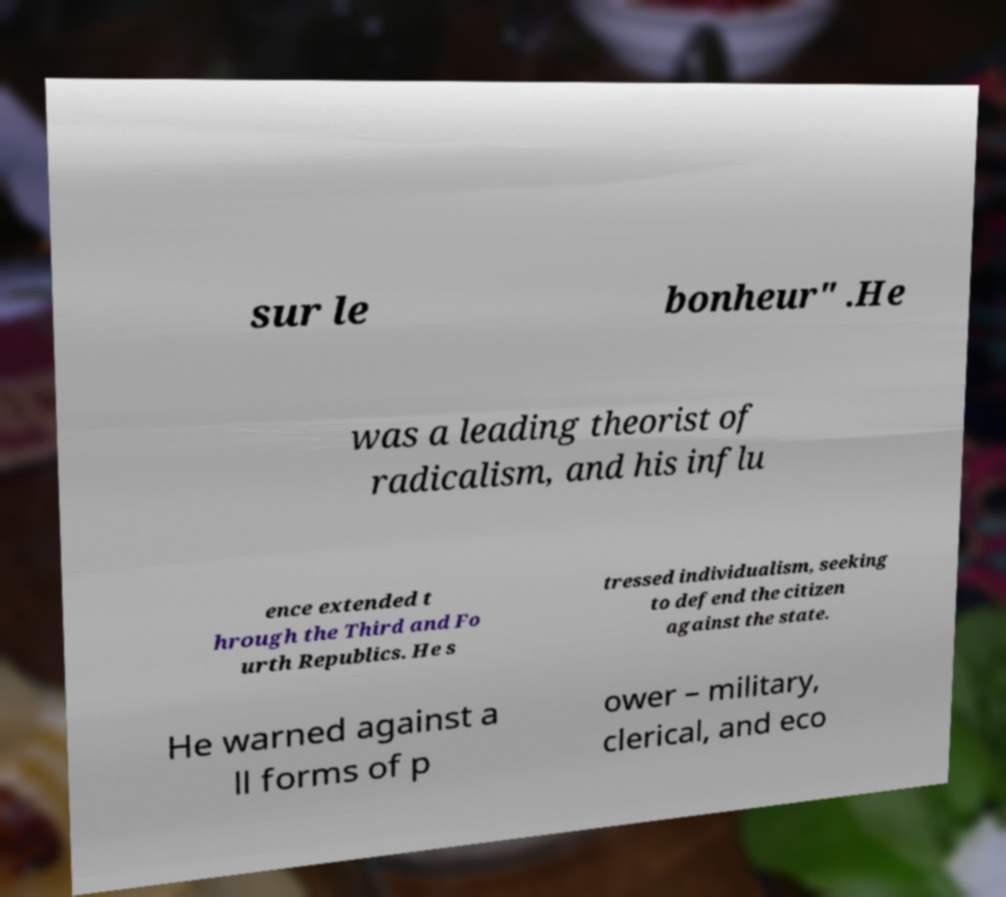What messages or text are displayed in this image? I need them in a readable, typed format. sur le bonheur" .He was a leading theorist of radicalism, and his influ ence extended t hrough the Third and Fo urth Republics. He s tressed individualism, seeking to defend the citizen against the state. He warned against a ll forms of p ower – military, clerical, and eco 